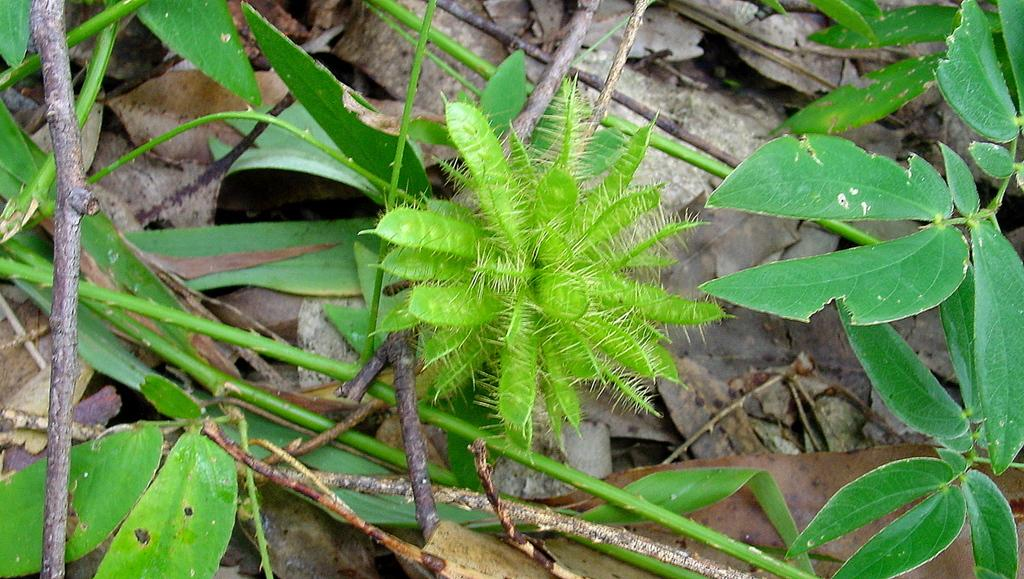What is the main subject in the center of the image? There is a flower in the center of the image. What can be seen in the background of the image? There are plants and dry leaves in the background of the image. What type of education is being provided on the stage in the image? There is no stage or education present in the image; it features a flower and plants in the background. 